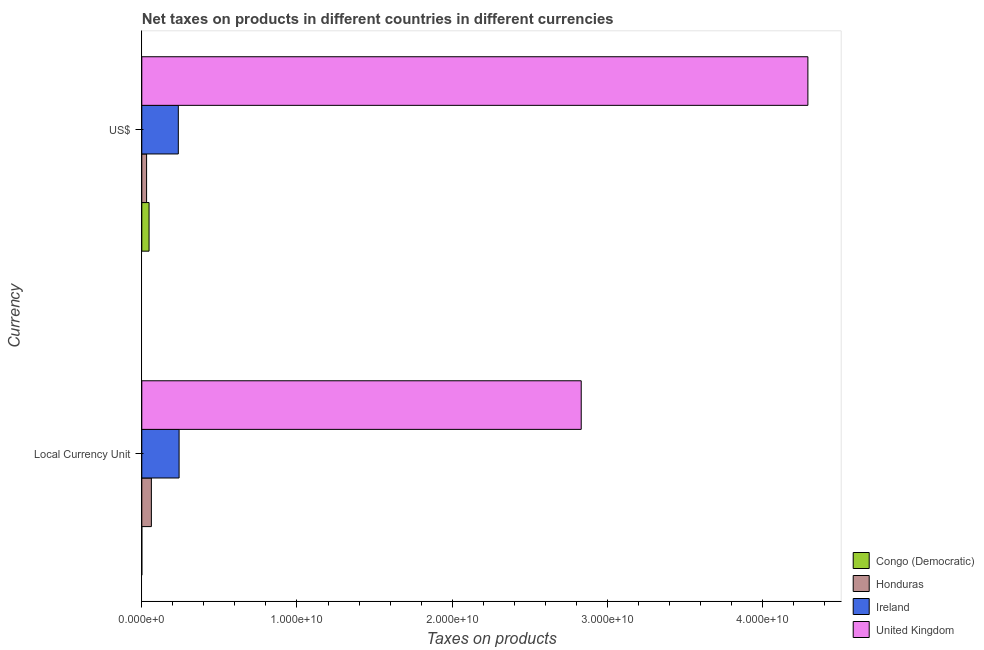How many different coloured bars are there?
Offer a terse response. 4. Are the number of bars on each tick of the Y-axis equal?
Keep it short and to the point. Yes. What is the label of the 2nd group of bars from the top?
Your answer should be very brief. Local Currency Unit. What is the net taxes in us$ in Congo (Democratic)?
Keep it short and to the point. 4.67e+08. Across all countries, what is the maximum net taxes in us$?
Make the answer very short. 4.29e+1. Across all countries, what is the minimum net taxes in constant 2005 us$?
Your answer should be very brief. 0.02. In which country was the net taxes in us$ minimum?
Provide a short and direct response. Honduras. What is the total net taxes in us$ in the graph?
Your answer should be very brief. 4.60e+1. What is the difference between the net taxes in constant 2005 us$ in United Kingdom and that in Ireland?
Provide a succinct answer. 2.59e+1. What is the difference between the net taxes in us$ in Congo (Democratic) and the net taxes in constant 2005 us$ in Honduras?
Offer a very short reply. -1.50e+08. What is the average net taxes in us$ per country?
Give a very brief answer. 1.15e+1. What is the difference between the net taxes in us$ and net taxes in constant 2005 us$ in Ireland?
Your answer should be very brief. -5.10e+07. In how many countries, is the net taxes in constant 2005 us$ greater than 34000000000 units?
Give a very brief answer. 0. What is the ratio of the net taxes in us$ in Congo (Democratic) to that in Ireland?
Keep it short and to the point. 0.2. In how many countries, is the net taxes in us$ greater than the average net taxes in us$ taken over all countries?
Your answer should be compact. 1. What does the 2nd bar from the bottom in US$ represents?
Your answer should be very brief. Honduras. How many bars are there?
Your answer should be compact. 8. Are the values on the major ticks of X-axis written in scientific E-notation?
Your answer should be very brief. Yes. Where does the legend appear in the graph?
Your answer should be compact. Bottom right. How many legend labels are there?
Provide a short and direct response. 4. How are the legend labels stacked?
Make the answer very short. Vertical. What is the title of the graph?
Provide a short and direct response. Net taxes on products in different countries in different currencies. What is the label or title of the X-axis?
Offer a very short reply. Taxes on products. What is the label or title of the Y-axis?
Offer a terse response. Currency. What is the Taxes on products in Congo (Democratic) in Local Currency Unit?
Offer a very short reply. 0.02. What is the Taxes on products of Honduras in Local Currency Unit?
Offer a terse response. 6.17e+08. What is the Taxes on products of Ireland in Local Currency Unit?
Your response must be concise. 2.40e+09. What is the Taxes on products in United Kingdom in Local Currency Unit?
Provide a succinct answer. 2.83e+1. What is the Taxes on products of Congo (Democratic) in US$?
Your answer should be compact. 4.67e+08. What is the Taxes on products in Honduras in US$?
Your answer should be very brief. 3.08e+08. What is the Taxes on products in Ireland in US$?
Keep it short and to the point. 2.35e+09. What is the Taxes on products of United Kingdom in US$?
Keep it short and to the point. 4.29e+1. Across all Currency, what is the maximum Taxes on products of Congo (Democratic)?
Provide a short and direct response. 4.67e+08. Across all Currency, what is the maximum Taxes on products in Honduras?
Your answer should be compact. 6.17e+08. Across all Currency, what is the maximum Taxes on products of Ireland?
Your answer should be compact. 2.40e+09. Across all Currency, what is the maximum Taxes on products of United Kingdom?
Provide a succinct answer. 4.29e+1. Across all Currency, what is the minimum Taxes on products in Congo (Democratic)?
Ensure brevity in your answer.  0.02. Across all Currency, what is the minimum Taxes on products in Honduras?
Your answer should be very brief. 3.08e+08. Across all Currency, what is the minimum Taxes on products in Ireland?
Offer a very short reply. 2.35e+09. Across all Currency, what is the minimum Taxes on products of United Kingdom?
Your response must be concise. 2.83e+1. What is the total Taxes on products in Congo (Democratic) in the graph?
Provide a succinct answer. 4.67e+08. What is the total Taxes on products of Honduras in the graph?
Ensure brevity in your answer.  9.26e+08. What is the total Taxes on products in Ireland in the graph?
Provide a succinct answer. 4.76e+09. What is the total Taxes on products of United Kingdom in the graph?
Ensure brevity in your answer.  7.12e+1. What is the difference between the Taxes on products of Congo (Democratic) in Local Currency Unit and that in US$?
Your response must be concise. -4.67e+08. What is the difference between the Taxes on products in Honduras in Local Currency Unit and that in US$?
Give a very brief answer. 3.08e+08. What is the difference between the Taxes on products of Ireland in Local Currency Unit and that in US$?
Make the answer very short. 5.10e+07. What is the difference between the Taxes on products in United Kingdom in Local Currency Unit and that in US$?
Provide a succinct answer. -1.46e+1. What is the difference between the Taxes on products of Congo (Democratic) in Local Currency Unit and the Taxes on products of Honduras in US$?
Your response must be concise. -3.08e+08. What is the difference between the Taxes on products in Congo (Democratic) in Local Currency Unit and the Taxes on products in Ireland in US$?
Keep it short and to the point. -2.35e+09. What is the difference between the Taxes on products in Congo (Democratic) in Local Currency Unit and the Taxes on products in United Kingdom in US$?
Give a very brief answer. -4.29e+1. What is the difference between the Taxes on products in Honduras in Local Currency Unit and the Taxes on products in Ireland in US$?
Provide a short and direct response. -1.74e+09. What is the difference between the Taxes on products of Honduras in Local Currency Unit and the Taxes on products of United Kingdom in US$?
Your response must be concise. -4.23e+1. What is the difference between the Taxes on products in Ireland in Local Currency Unit and the Taxes on products in United Kingdom in US$?
Ensure brevity in your answer.  -4.05e+1. What is the average Taxes on products of Congo (Democratic) per Currency?
Your answer should be compact. 2.34e+08. What is the average Taxes on products of Honduras per Currency?
Give a very brief answer. 4.63e+08. What is the average Taxes on products of Ireland per Currency?
Your answer should be compact. 2.38e+09. What is the average Taxes on products of United Kingdom per Currency?
Your response must be concise. 3.56e+1. What is the difference between the Taxes on products of Congo (Democratic) and Taxes on products of Honduras in Local Currency Unit?
Your response must be concise. -6.17e+08. What is the difference between the Taxes on products in Congo (Democratic) and Taxes on products in Ireland in Local Currency Unit?
Your answer should be compact. -2.40e+09. What is the difference between the Taxes on products of Congo (Democratic) and Taxes on products of United Kingdom in Local Currency Unit?
Make the answer very short. -2.83e+1. What is the difference between the Taxes on products of Honduras and Taxes on products of Ireland in Local Currency Unit?
Your answer should be compact. -1.79e+09. What is the difference between the Taxes on products in Honduras and Taxes on products in United Kingdom in Local Currency Unit?
Offer a terse response. -2.77e+1. What is the difference between the Taxes on products of Ireland and Taxes on products of United Kingdom in Local Currency Unit?
Give a very brief answer. -2.59e+1. What is the difference between the Taxes on products of Congo (Democratic) and Taxes on products of Honduras in US$?
Ensure brevity in your answer.  1.59e+08. What is the difference between the Taxes on products of Congo (Democratic) and Taxes on products of Ireland in US$?
Keep it short and to the point. -1.88e+09. What is the difference between the Taxes on products in Congo (Democratic) and Taxes on products in United Kingdom in US$?
Give a very brief answer. -4.25e+1. What is the difference between the Taxes on products of Honduras and Taxes on products of Ireland in US$?
Provide a succinct answer. -2.04e+09. What is the difference between the Taxes on products of Honduras and Taxes on products of United Kingdom in US$?
Your answer should be very brief. -4.26e+1. What is the difference between the Taxes on products of Ireland and Taxes on products of United Kingdom in US$?
Keep it short and to the point. -4.06e+1. What is the ratio of the Taxes on products of Honduras in Local Currency Unit to that in US$?
Provide a short and direct response. 2. What is the ratio of the Taxes on products of Ireland in Local Currency Unit to that in US$?
Give a very brief answer. 1.02. What is the ratio of the Taxes on products in United Kingdom in Local Currency Unit to that in US$?
Offer a terse response. 0.66. What is the difference between the highest and the second highest Taxes on products of Congo (Democratic)?
Offer a terse response. 4.67e+08. What is the difference between the highest and the second highest Taxes on products of Honduras?
Give a very brief answer. 3.08e+08. What is the difference between the highest and the second highest Taxes on products of Ireland?
Give a very brief answer. 5.10e+07. What is the difference between the highest and the second highest Taxes on products in United Kingdom?
Ensure brevity in your answer.  1.46e+1. What is the difference between the highest and the lowest Taxes on products of Congo (Democratic)?
Provide a succinct answer. 4.67e+08. What is the difference between the highest and the lowest Taxes on products in Honduras?
Your response must be concise. 3.08e+08. What is the difference between the highest and the lowest Taxes on products in Ireland?
Offer a terse response. 5.10e+07. What is the difference between the highest and the lowest Taxes on products of United Kingdom?
Your answer should be very brief. 1.46e+1. 